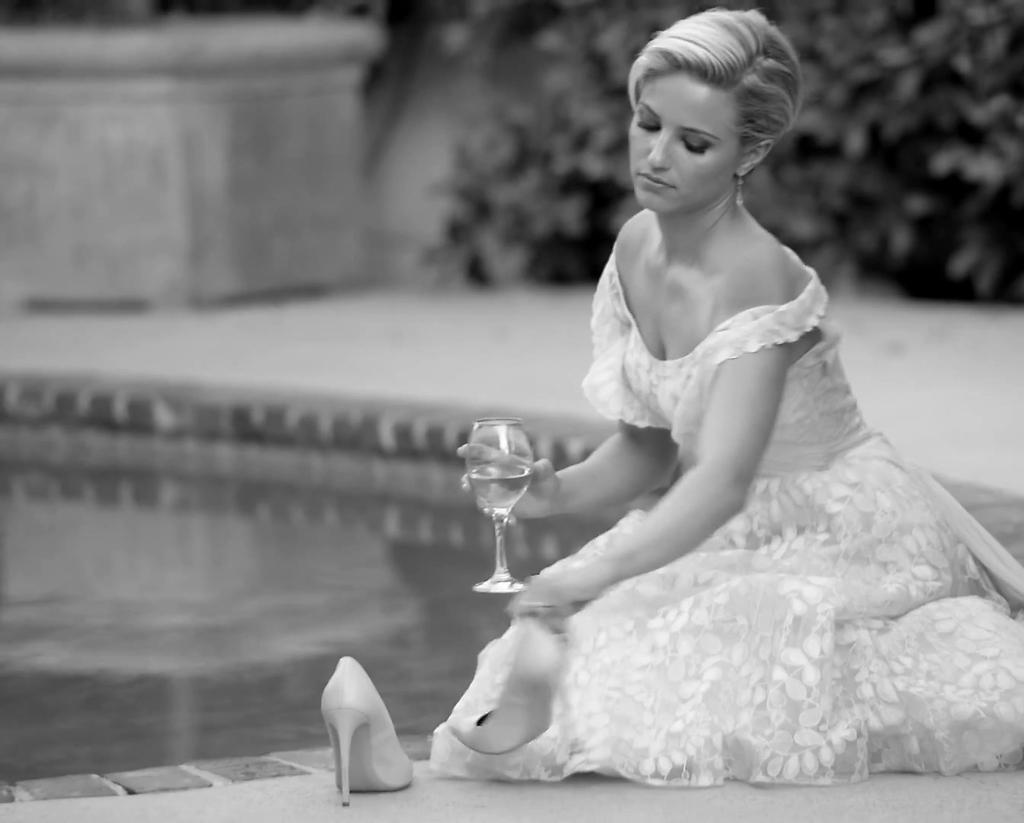Who is present in the image? There is a woman in the image. What is the woman wearing? The woman is wearing a white gown. What is the woman's position in the image? The woman is sitting on the floor. What is in front of the woman? There is a pool in front of the woman. What can be seen in the background of the image? There are plants in the background of the image. What type of rake is the woman using to stimulate the growth of the plants in the image? There is no rake present in the image, and the woman is not interacting with the plants in any way. 